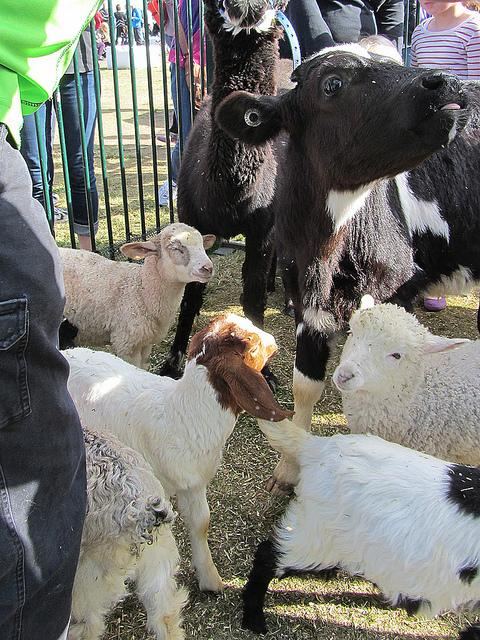What does the girl come to this venue for?

Choices:
A) raising animals
B) feeding animals
C) petting animals
D) riding animals petting animals 